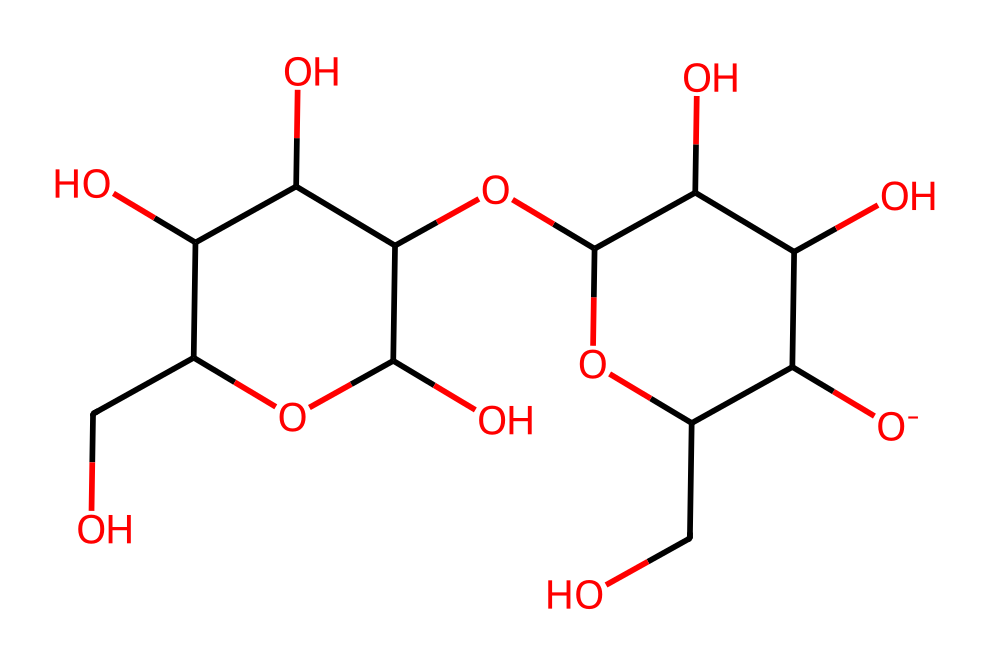What type of polymer is represented by this SMILES? The SMILES corresponds to a chemical structure that contains repeating units of glucose, which are characteristic of polysaccharides. This structure is a polymer of glucose molecules, thus it is a polysaccharide.
Answer: polysaccharide How many carbon atoms are in this chemical structure? By examining the structure, we can count the carbon atoms present. This SMILES contains six carbon atoms in the cyclic portion and additional carbon atoms in the branching, totaling 12 carbon atoms.
Answer: 12 What is the primary function of cellulose in wooden basketball courts? Cellulose provides structural support and strength to the wood, contributing to its durability and stability. Its fibrous nature helps in distributing load and resisting wear and tear in usage scenarios like basketball courts.
Answer: structural support What type of linkage connects glucose units in cellulose? The linkage that connects glucose units in cellulose is a beta-1,4-glycosidic bond, a specific type of glycosidic bond prevalent in the cellulose polymer.
Answer: beta-1,4-glycosidic bond How many hydroxyl groups are present in the cellulose structure? By examining the SMILES, we can identify multiple -OH groups attached to the glucose units. The structure shows a total of 5 hydroxyl groups.
Answer: 5 